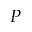<formula> <loc_0><loc_0><loc_500><loc_500>P</formula> 